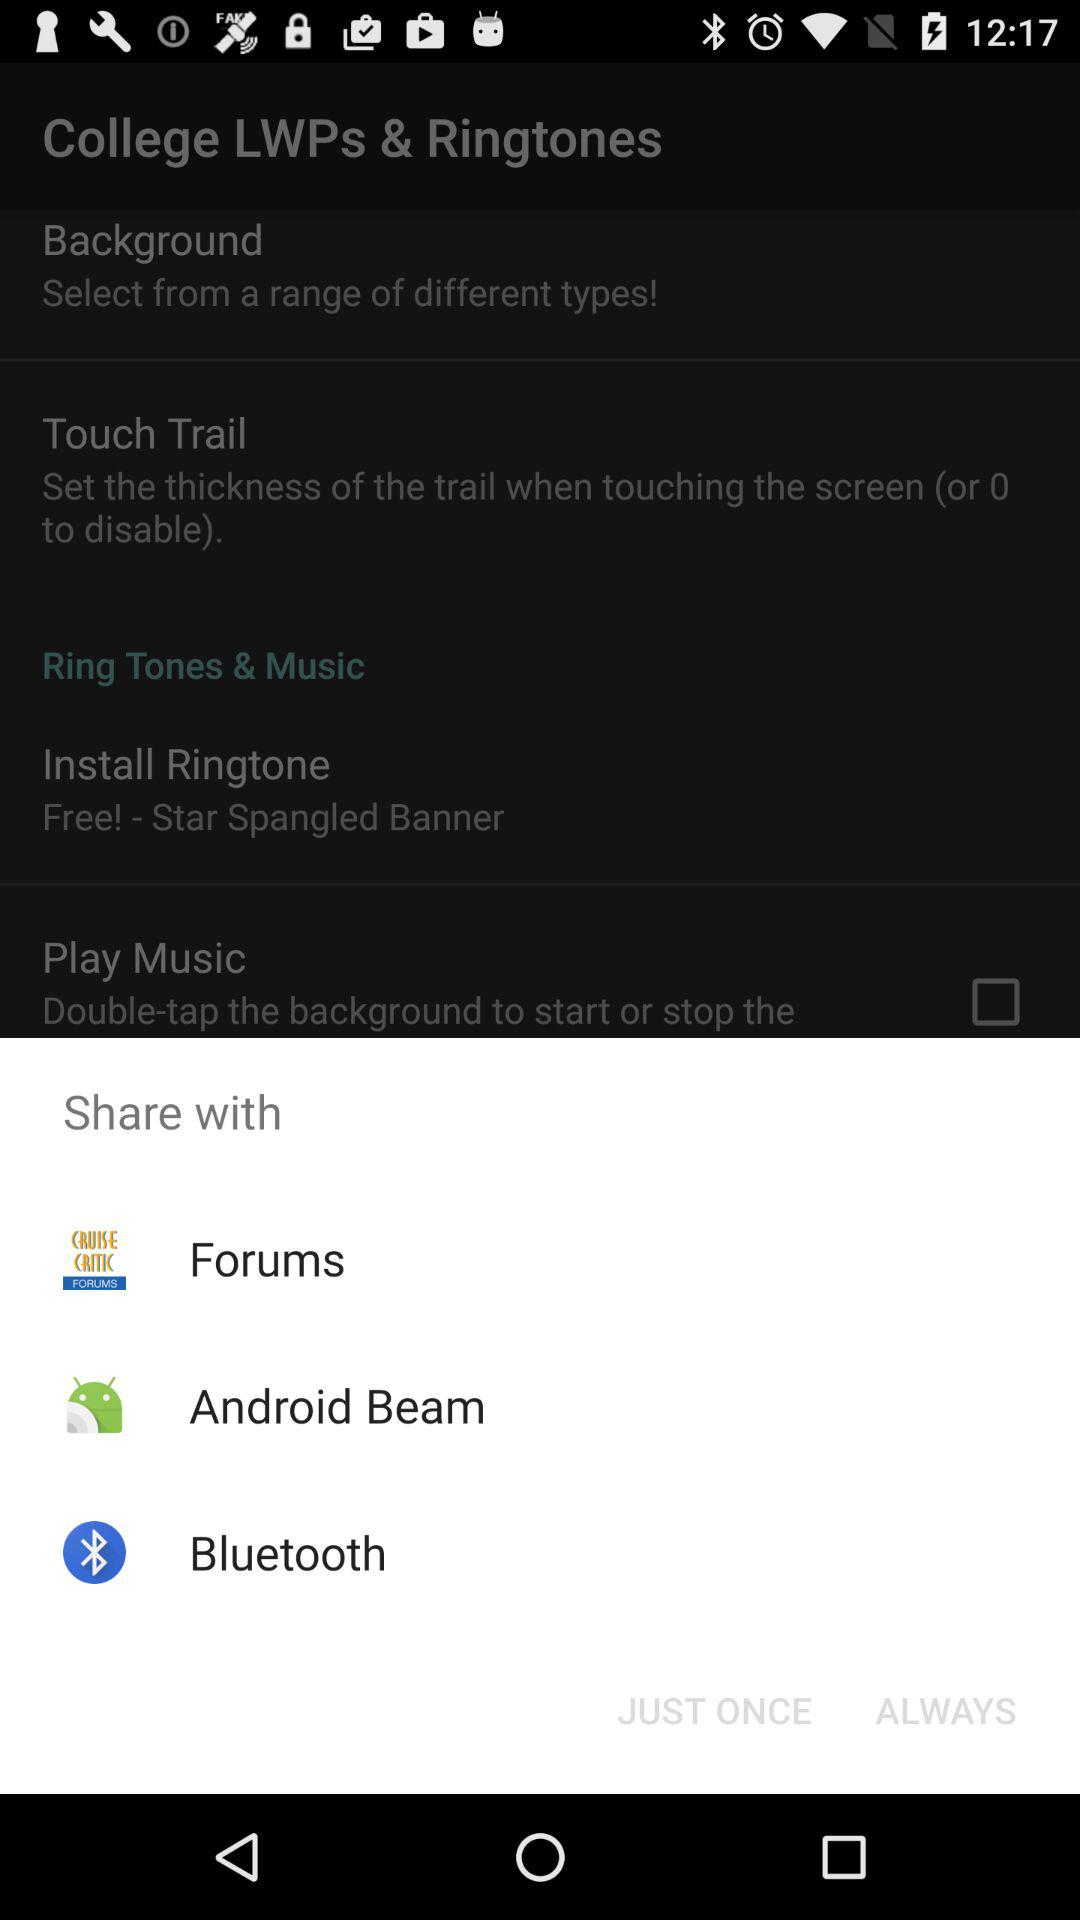How many items are in the Share with section?
Answer the question using a single word or phrase. 3 